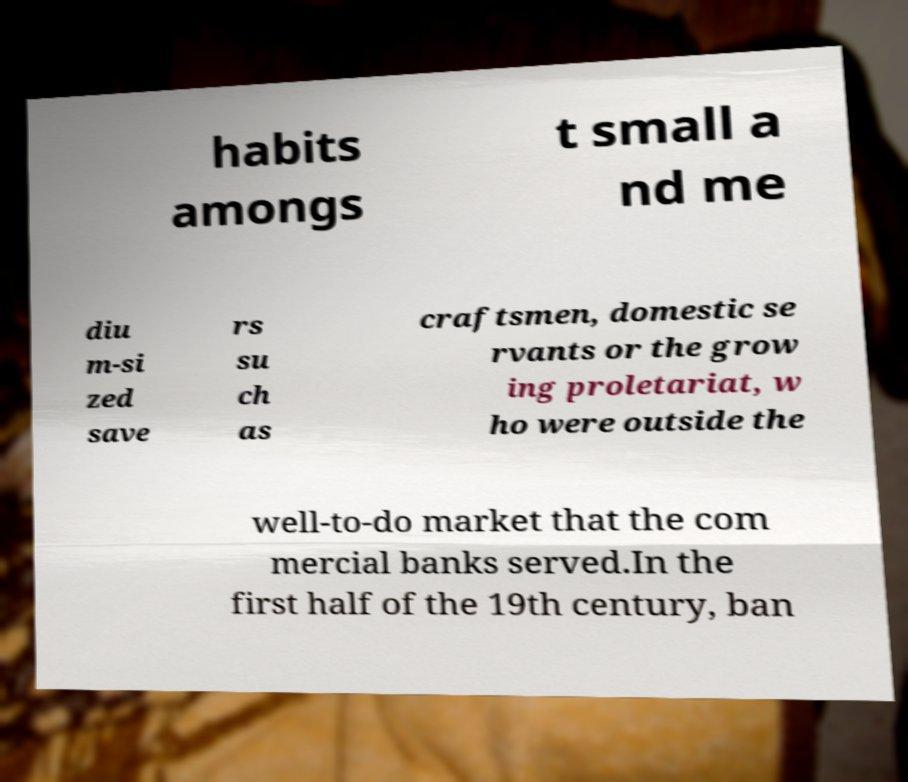What messages or text are displayed in this image? I need them in a readable, typed format. habits amongs t small a nd me diu m-si zed save rs su ch as craftsmen, domestic se rvants or the grow ing proletariat, w ho were outside the well-to-do market that the com mercial banks served.In the first half of the 19th century, ban 